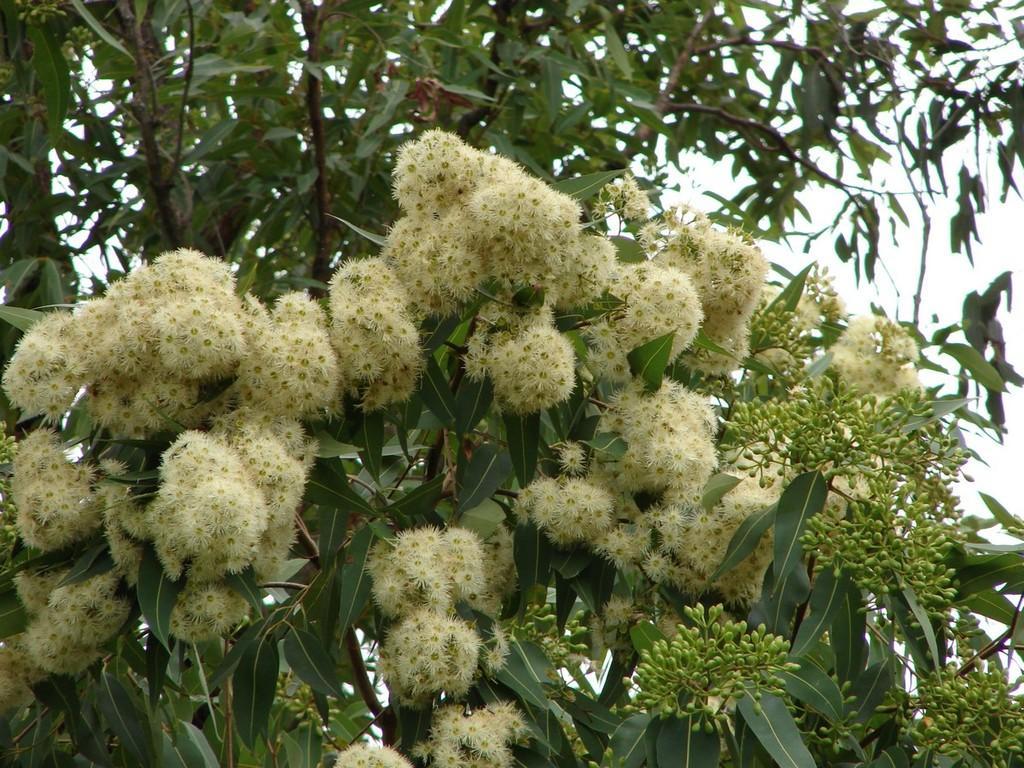Describe this image in one or two sentences. In this picture we can see a bunch of flowers to the tree. 